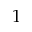<formula> <loc_0><loc_0><loc_500><loc_500>1</formula> 